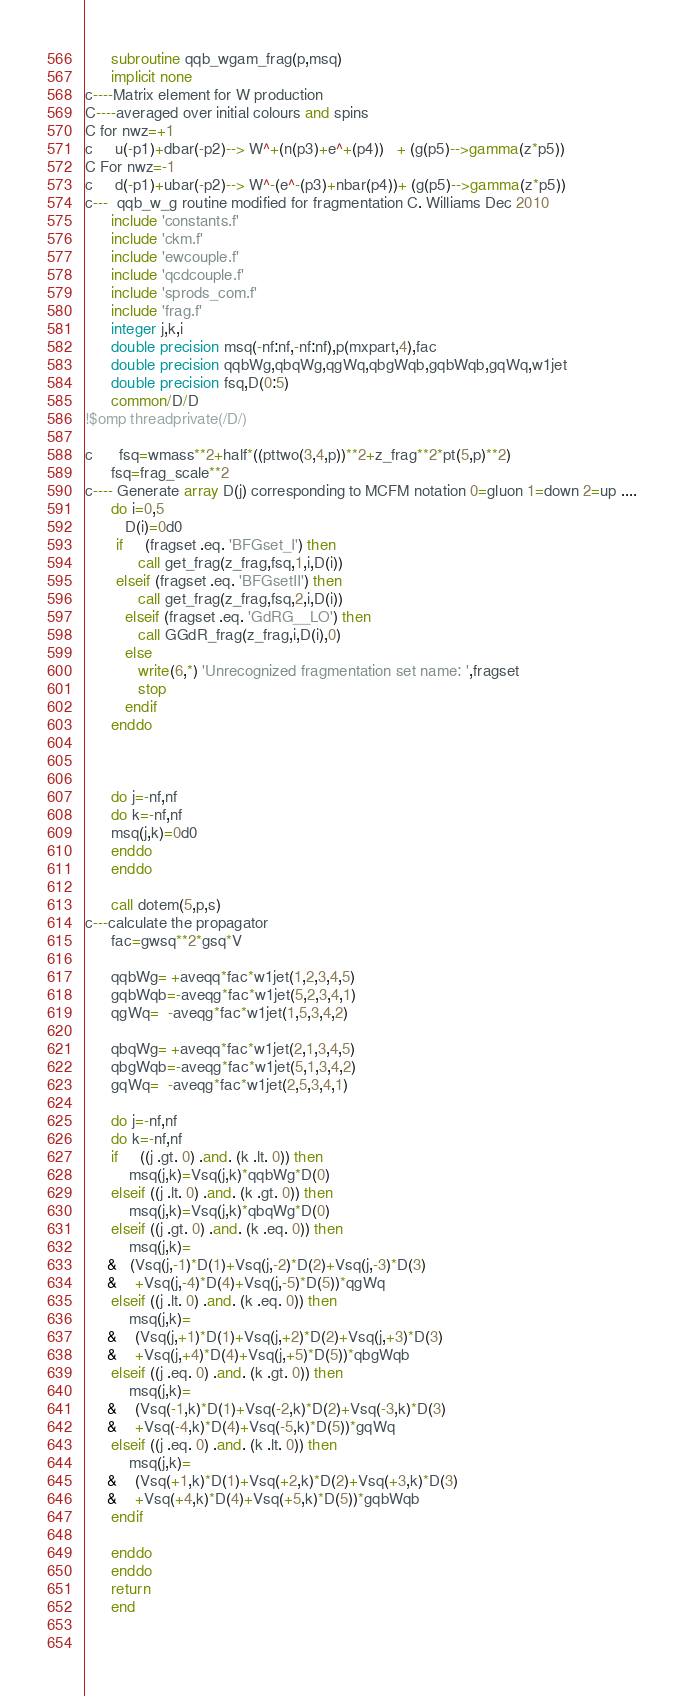Convert code to text. <code><loc_0><loc_0><loc_500><loc_500><_FORTRAN_>      subroutine qqb_wgam_frag(p,msq)
      implicit none
c----Matrix element for W production
C----averaged over initial colours and spins
C for nwz=+1
c     u(-p1)+dbar(-p2)--> W^+(n(p3)+e^+(p4))   + (g(p5)-->gamma(z*p5))
C For nwz=-1
c     d(-p1)+ubar(-p2)--> W^-(e^-(p3)+nbar(p4))+ (g(p5)-->gamma(z*p5)) 
c---  qqb_w_g routine modified for fragmentation C. Williams Dec 2010
      include 'constants.f'
      include 'ckm.f'
      include 'ewcouple.f'
      include 'qcdcouple.f'
      include 'sprods_com.f'
      include 'frag.f'
      integer j,k,i
      double precision msq(-nf:nf,-nf:nf),p(mxpart,4),fac
      double precision qqbWg,qbqWg,qgWq,qbgWqb,gqbWqb,gqWq,w1jet
      double precision fsq,D(0:5)
      common/D/D
!$omp threadprivate(/D/)

c      fsq=wmass**2+half*((pttwo(3,4,p))**2+z_frag**2*pt(5,p)**2)
      fsq=frag_scale**2
c---- Generate array D(j) corresponding to MCFM notation 0=gluon 1=down 2=up ....
      do i=0,5
         D(i)=0d0
       if     (fragset .eq. 'BFGset_I') then
            call get_frag(z_frag,fsq,1,i,D(i))   
       elseif (fragset .eq. 'BFGsetII') then  
            call get_frag(z_frag,fsq,2,i,D(i))   
         elseif (fragset .eq. 'GdRG__LO') then 
            call GGdR_frag(z_frag,i,D(i),0) 
         else
            write(6,*) 'Unrecognized fragmentation set name: ',fragset
            stop
         endif
      enddo

     

      do j=-nf,nf
      do k=-nf,nf
      msq(j,k)=0d0
      enddo
      enddo

      call dotem(5,p,s)
c---calculate the propagator
      fac=gwsq**2*gsq*V

      qqbWg= +aveqq*fac*w1jet(1,2,3,4,5)
      gqbWqb=-aveqg*fac*w1jet(5,2,3,4,1)
      qgWq=  -aveqg*fac*w1jet(1,5,3,4,2)
      
      qbqWg= +aveqq*fac*w1jet(2,1,3,4,5)
      qbgWqb=-aveqg*fac*w1jet(5,1,3,4,2)
      gqWq=  -aveqg*fac*w1jet(2,5,3,4,1)

      do j=-nf,nf
      do k=-nf,nf
      if     ((j .gt. 0) .and. (k .lt. 0)) then
          msq(j,k)=Vsq(j,k)*qqbWg*D(0)
      elseif ((j .lt. 0) .and. (k .gt. 0)) then
          msq(j,k)=Vsq(j,k)*qbqWg*D(0)
      elseif ((j .gt. 0) .and. (k .eq. 0)) then
          msq(j,k)=
     &   (Vsq(j,-1)*D(1)+Vsq(j,-2)*D(2)+Vsq(j,-3)*D(3)
     &    +Vsq(j,-4)*D(4)+Vsq(j,-5)*D(5))*qgWq
      elseif ((j .lt. 0) .and. (k .eq. 0)) then
          msq(j,k)=
     &    (Vsq(j,+1)*D(1)+Vsq(j,+2)*D(2)+Vsq(j,+3)*D(3)
     &    +Vsq(j,+4)*D(4)+Vsq(j,+5)*D(5))*qbgWqb
      elseif ((j .eq. 0) .and. (k .gt. 0)) then
          msq(j,k)=
     &    (Vsq(-1,k)*D(1)+Vsq(-2,k)*D(2)+Vsq(-3,k)*D(3)
     &    +Vsq(-4,k)*D(4)+Vsq(-5,k)*D(5))*gqWq
      elseif ((j .eq. 0) .and. (k .lt. 0)) then
          msq(j,k)=
     &    (Vsq(+1,k)*D(1)+Vsq(+2,k)*D(2)+Vsq(+3,k)*D(3)
     &    +Vsq(+4,k)*D(4)+Vsq(+5,k)*D(5))*gqbWqb
      endif

      enddo
      enddo
      return
      end
 
     

</code> 